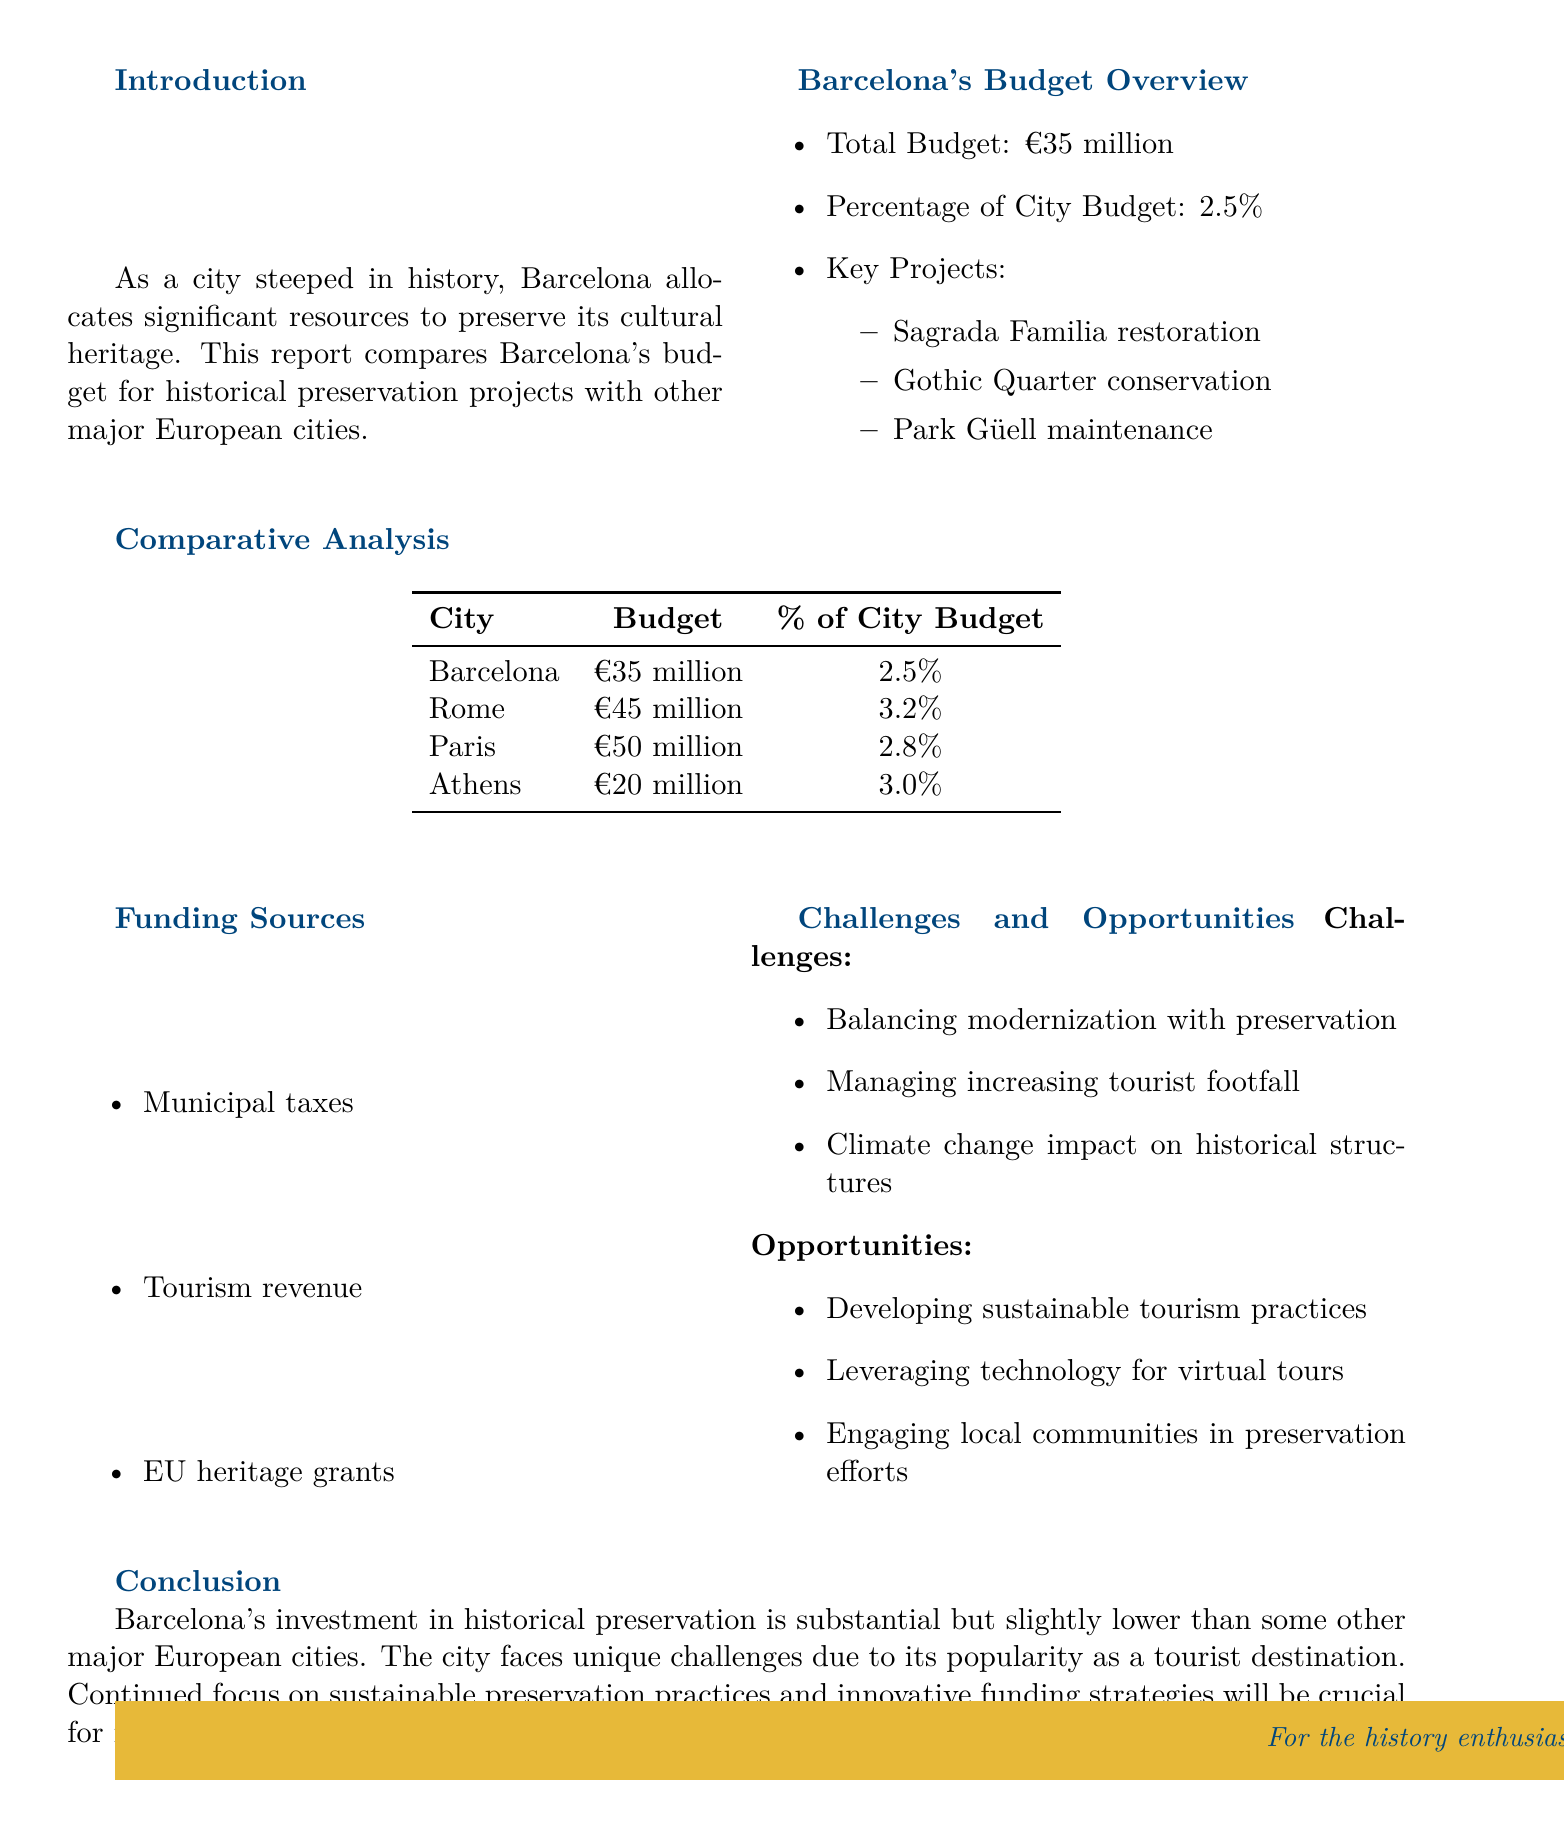What is Barcelona's total budget for historical preservation? The total budget for historical preservation in Barcelona is explicitly stated in the budget overview section of the document.
Answer: €35 million What percentage of Barcelona's city budget is allocated to historical preservation? The percentage allocated to historical preservation is mentioned in the budget overview section, indicating the share of the overall city budget.
Answer: 2.5% Which key project in Barcelona is focused on restoration? The key projects listed under the budget overview specify the focus areas for historical preservation, including a notable one focused on restoration.
Answer: Sagrada Familia restoration How much does Rome allocate for historical preservation compared to Barcelona? The budget comparison table indicates the amount allocated by Rome alongside Barcelona's allocation, allowing for direct comparison.
Answer: €10 million more What is the total budget of Athens for historical preservation? The budget comparison table contains the data specific to Athens, detailing its financial allocation for preservation efforts.
Answer: €20 million What are two of the challenges faced by Barcelona in historical preservation? The challenges listed in the challenges and opportunities section provide insights into issues affecting preservation efforts in Barcelona.
Answer: Balancing modernization and managing increasing tourist footfall What funding source is related to tourism in Barcelona? The funding sources listed in the document detail the different financial contributors, with one specifically relating to the tourism sector.
Answer: Tourism revenue Which two cities have a higher percentage of city budget allocation than Barcelona? The budget comparison shows that some cities allocate a greater percentage of their city budget to preservation, indicating which cities meet this criterion.
Answer: Rome and Athens What is the future outlook mentioned for Barcelona's historical preservation? The conclusion section outlines the future outlook for preservation practices in Barcelona, focusing on ongoing strategies necessary for success.
Answer: Sustainable preservation practices and innovative funding strategies 